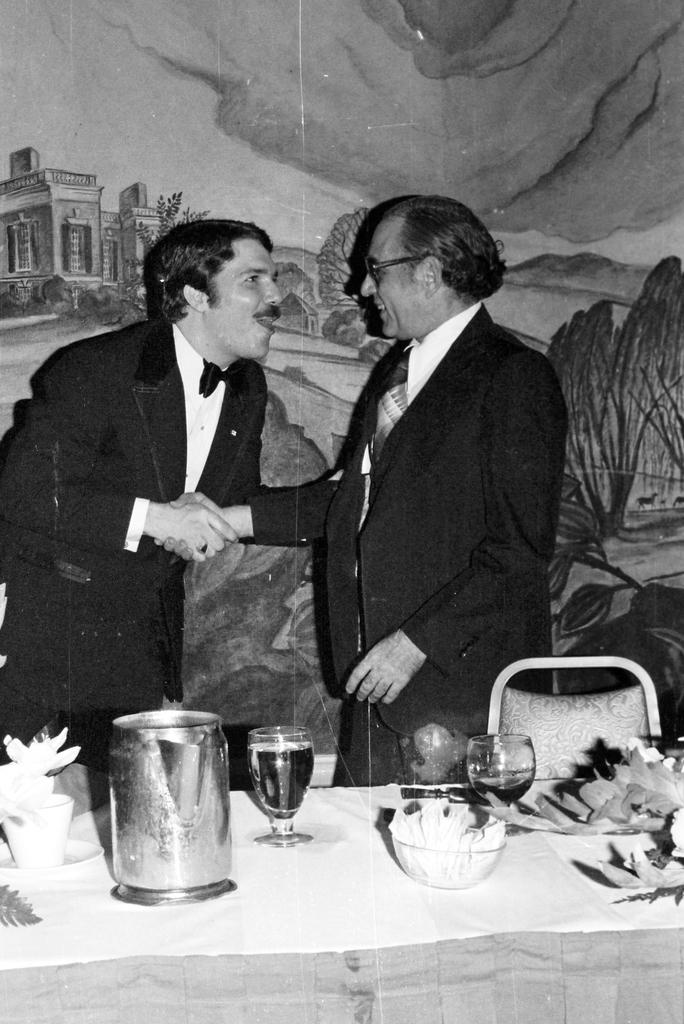How many people are in the image? There are two persons standing in the image. What are the two persons doing? The two persons are shaking hands. What objects can be seen on the table? There is a jug, a glass, a paper, and a bowl on the table. Is there any furniture in the image? Yes, there is a chair in the image. What can be seen in the background of the image? There is wallpaper in the background of the image. What is the fifth person in the image doing? There are only two persons in the image, so there is no fifth person to describe. 